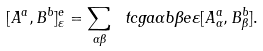<formula> <loc_0><loc_0><loc_500><loc_500>[ A ^ { a } , B ^ { b } ] ^ { e } _ { \varepsilon } = \sum _ { \alpha \beta } \ t c g a \alpha b \beta e \varepsilon [ A ^ { a } _ { \alpha } , B ^ { b } _ { \beta } ] .</formula> 